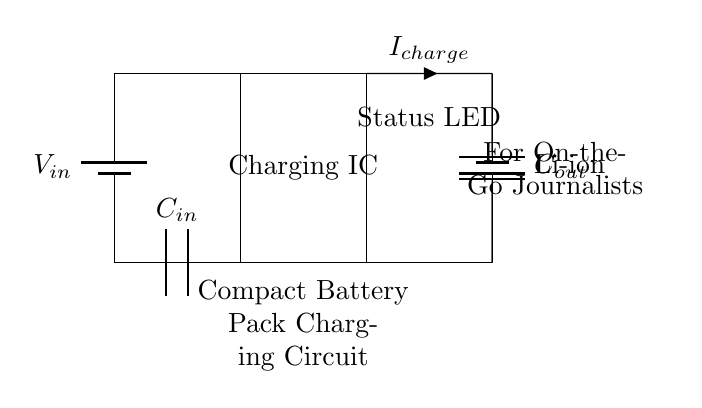What is the input voltage of the circuit? The input voltage is labeled as V in on the battery. It implies that the battery provides the primary voltage source for the charging circuit.
Answer: V in What type of capacitor is used at the input? The component labeled as C in in the circuit represents the input capacitor. This is essential for stabilizing the input voltage to the charging IC.
Answer: Capacitor What is the main purpose of the charging IC? The charging IC is responsible for managing the charging process of the connected battery to ensure safe and efficient charging.
Answer: Manage charging What type of battery is represented at the output? The battery at the output is labeled as Li-ion, indicating that it is a lithium-ion battery which is commonly used in portable devices.
Answer: Li-ion How many capacitors are present in the circuit? The circuit contains two capacitors as indicated by the labels C in and C out, which are used for input and output filtering, respectively.
Answer: Two What does the status LED indicate? The status LED shows the charging status of the lithium-ion battery, providing visual feedback on whether it is charging properly or fully charged.
Answer: Charging status What current is represented in the circuit? The circuit has a current labeled I charge, which shows the output charging current flowing to the battery during the charging process.
Answer: I charge 